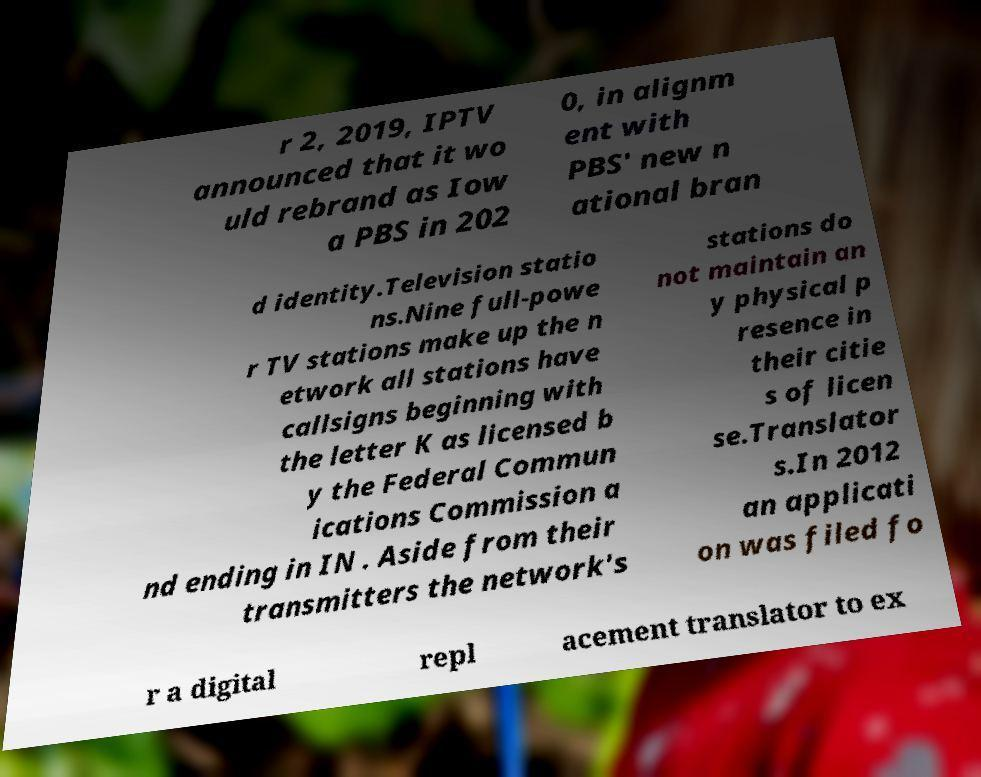Could you extract and type out the text from this image? r 2, 2019, IPTV announced that it wo uld rebrand as Iow a PBS in 202 0, in alignm ent with PBS' new n ational bran d identity.Television statio ns.Nine full-powe r TV stations make up the n etwork all stations have callsigns beginning with the letter K as licensed b y the Federal Commun ications Commission a nd ending in IN . Aside from their transmitters the network's stations do not maintain an y physical p resence in their citie s of licen se.Translator s.In 2012 an applicati on was filed fo r a digital repl acement translator to ex 